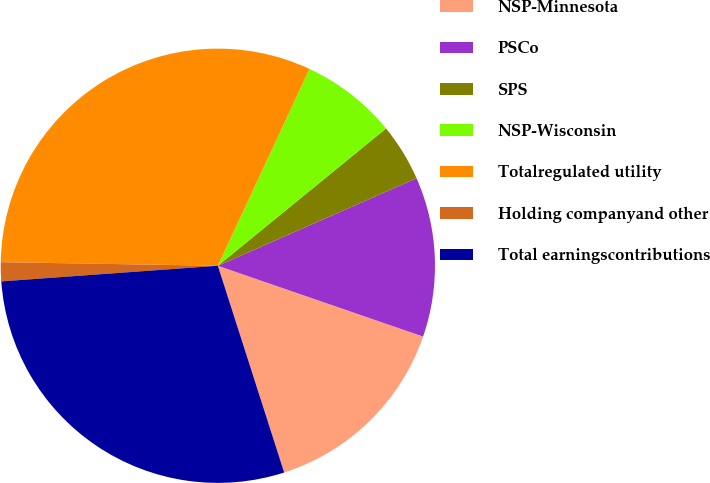Convert chart to OTSL. <chart><loc_0><loc_0><loc_500><loc_500><pie_chart><fcel>NSP-Minnesota<fcel>PSCo<fcel>SPS<fcel>NSP-Wisconsin<fcel>Totalregulated utility<fcel>Holding companyand other<fcel>Total earningscontributions<nl><fcel>14.77%<fcel>11.89%<fcel>4.29%<fcel>7.17%<fcel>31.67%<fcel>1.41%<fcel>28.79%<nl></chart> 